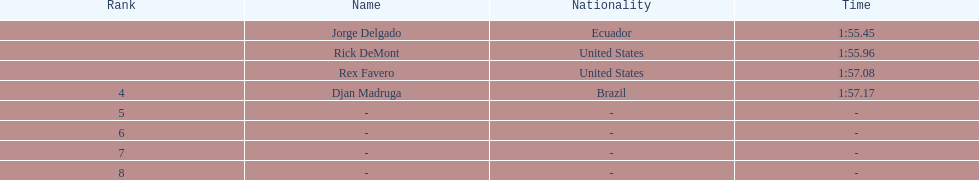For each name, what is the corresponding time? 1:55.45, 1:55.96, 1:57.08, 1:57.17. 